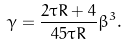<formula> <loc_0><loc_0><loc_500><loc_500>\gamma = \frac { 2 \tau R + 4 } { 4 5 \tau R } \beta ^ { 3 } .</formula> 